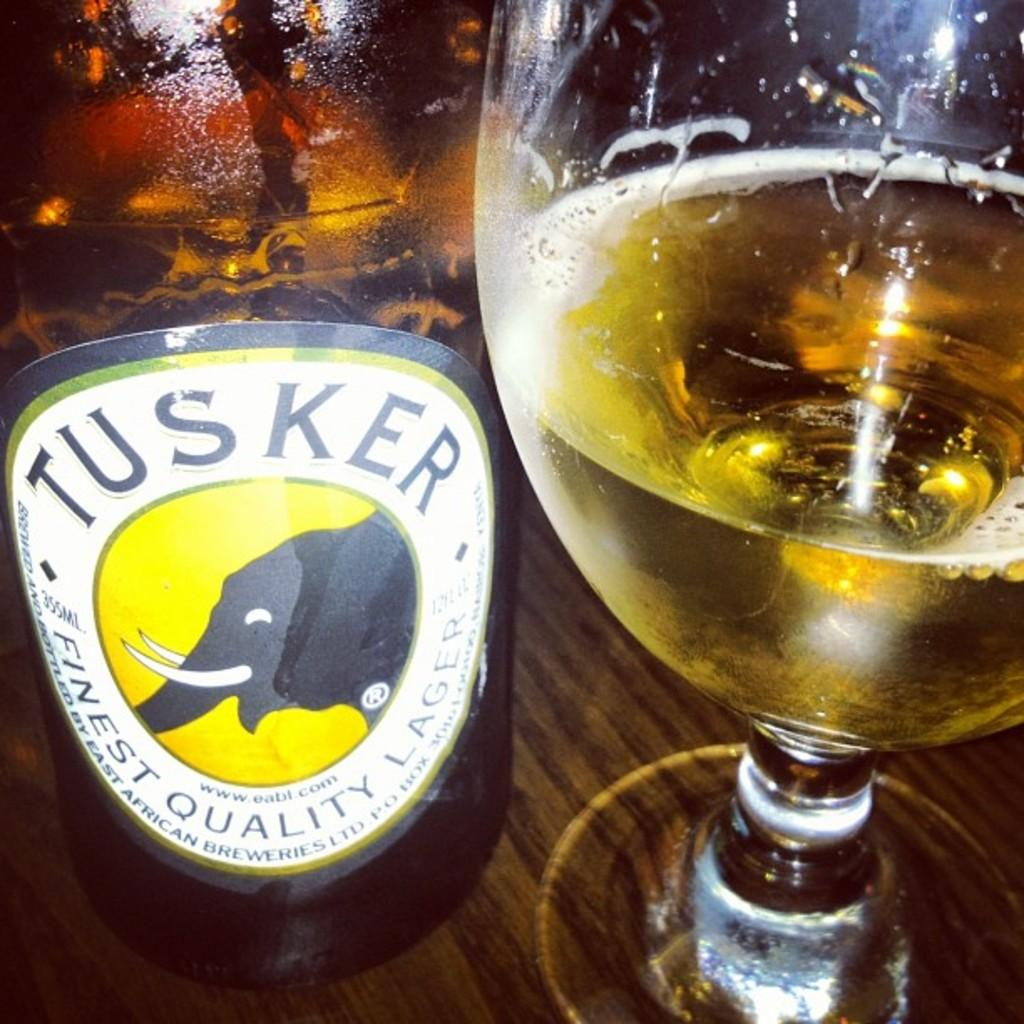<image>
Create a compact narrative representing the image presented. A bottle of Tusker lager has an elephant on the label. 